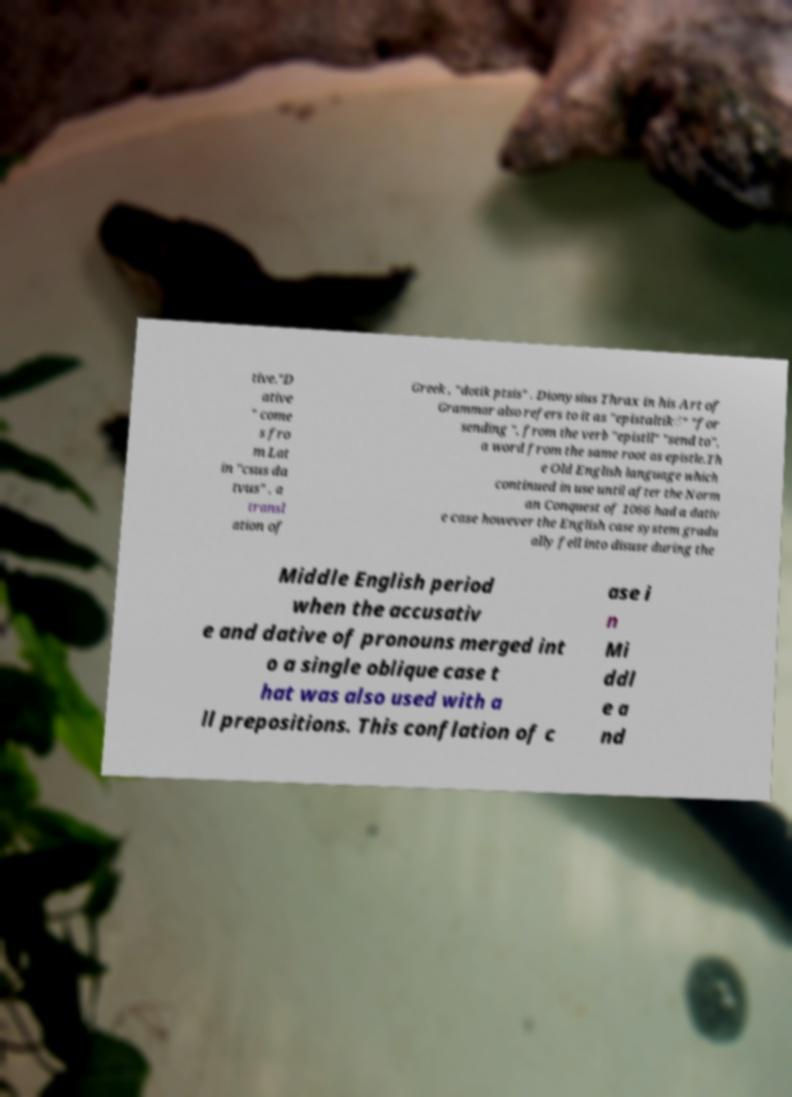There's text embedded in this image that I need extracted. Can you transcribe it verbatim? tive."D ative " come s fro m Lat in "csus da tvus" , a transl ation of Greek , "dotik ptsis" . Dionysius Thrax in his Art of Grammar also refers to it as "epistaltiḱ" "for sending ", from the verb "epistll" "send to", a word from the same root as epistle.Th e Old English language which continued in use until after the Norm an Conquest of 1066 had a dativ e case however the English case system gradu ally fell into disuse during the Middle English period when the accusativ e and dative of pronouns merged int o a single oblique case t hat was also used with a ll prepositions. This conflation of c ase i n Mi ddl e a nd 